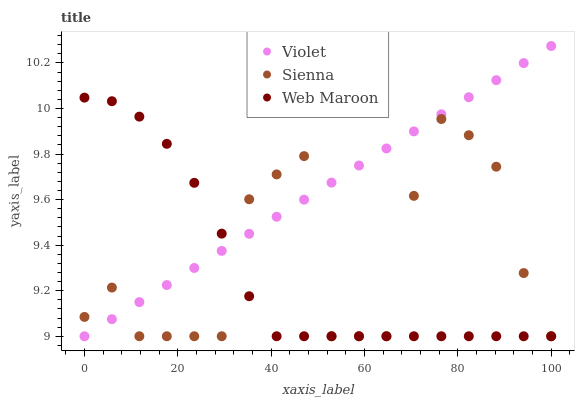Does Web Maroon have the minimum area under the curve?
Answer yes or no. Yes. Does Violet have the maximum area under the curve?
Answer yes or no. Yes. Does Violet have the minimum area under the curve?
Answer yes or no. No. Does Web Maroon have the maximum area under the curve?
Answer yes or no. No. Is Violet the smoothest?
Answer yes or no. Yes. Is Sienna the roughest?
Answer yes or no. Yes. Is Web Maroon the smoothest?
Answer yes or no. No. Is Web Maroon the roughest?
Answer yes or no. No. Does Sienna have the lowest value?
Answer yes or no. Yes. Does Violet have the highest value?
Answer yes or no. Yes. Does Web Maroon have the highest value?
Answer yes or no. No. Does Web Maroon intersect Violet?
Answer yes or no. Yes. Is Web Maroon less than Violet?
Answer yes or no. No. Is Web Maroon greater than Violet?
Answer yes or no. No. 